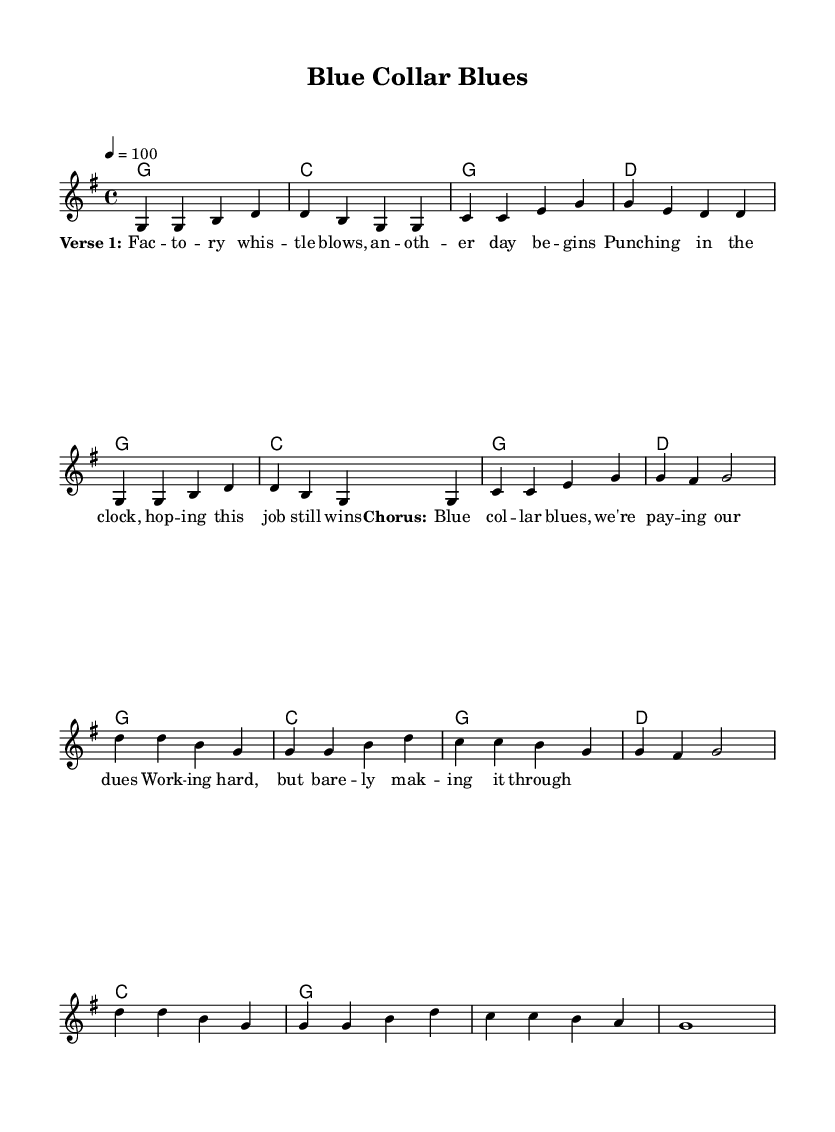What is the key signature of this music? The key signature indicates the pitches used in the piece. In this case, the key signature has one sharp (F#), indicating that it is in G major.
Answer: G major What is the time signature of this music? The time signature is located at the beginning of the score and shows how many beats are in each measure. Here, it shows 4/4, meaning there are 4 beats per measure, and the quarter note gets one beat.
Answer: 4/4 What is the tempo marking of this music? The tempo marking indicates the speed of the music and is provided as a metronome marking. In this sheet, it says "4 = 100," which means there are 100 beats per minute.
Answer: 100 How many measures are in the verse? By counting the short segments separated by the vertical lines (bar lines) in the verse section of the sheet music, we find there are 8 measures.
Answer: 8 What is the last chord in the chorus? The last chord is determined by examining the chord indications under the melody in the chorus section. The final chord is indicated as "g1," which shows a G major chord played for a whole measure.
Answer: g How many verses are indicated in the lyrics section? The lyrics section shows a clear structure divided into verses and choruses. Here, only one verse (Verse 1) is indicated, suggesting a total of one verse is presented in the music.
Answer: 1 What lyrical theme is suggested by the title? The title "Blue Collar Blues" suggests a theme focused on working-class struggles, as it references the hardships and emotional challenges faced by blue-collar workers in America.
Answer: Working-class struggles 